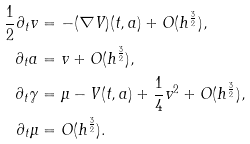<formula> <loc_0><loc_0><loc_500><loc_500>\frac { 1 } { 2 } \partial _ { t } v & = - ( \nabla V ) ( t , a ) + O ( h ^ { \frac { 3 } { 2 } } ) , \\ \partial _ { t } a & = v + O ( h ^ { \frac { 3 } { 2 } } ) , \\ \partial _ { t } \gamma & = \mu - V ( t , a ) + \frac { 1 } { 4 } v ^ { 2 } + O ( h ^ { \frac { 3 } { 2 } } ) , \\ \partial _ { t } { \mu } & = O ( h ^ { \frac { 3 } { 2 } } ) .</formula> 